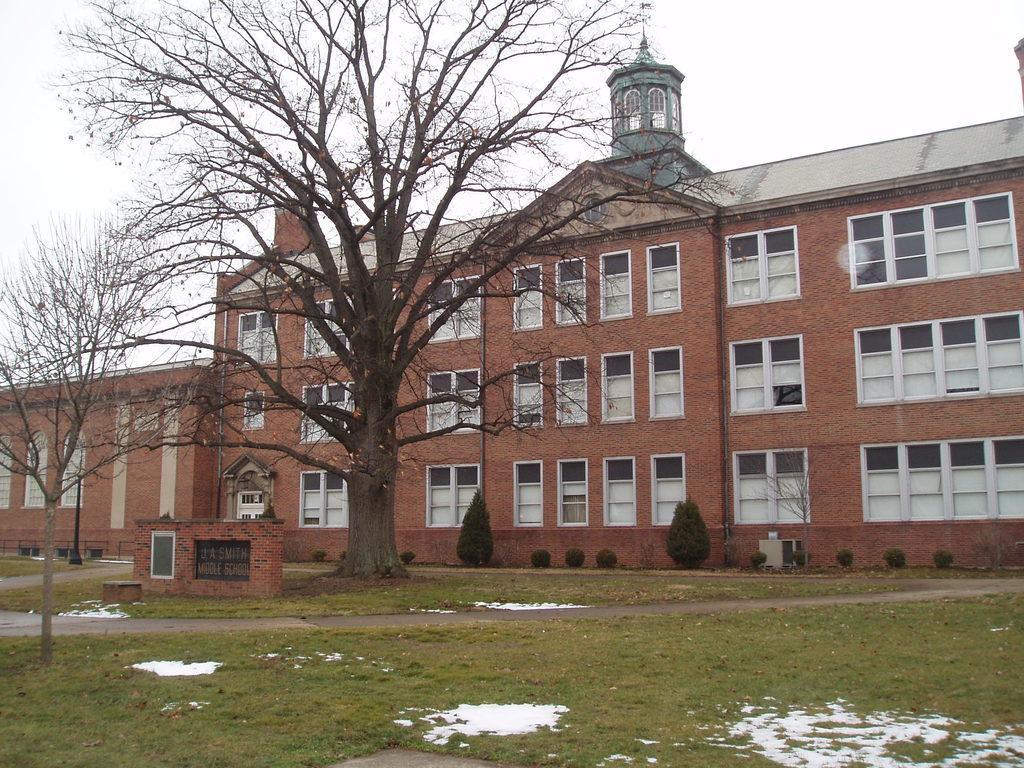Describe this image in one or two sentences. In this image, I can see a building with windows. In front of the building, there are trees, bushes, name board and snow on the grass. In the background, there is the sky. 